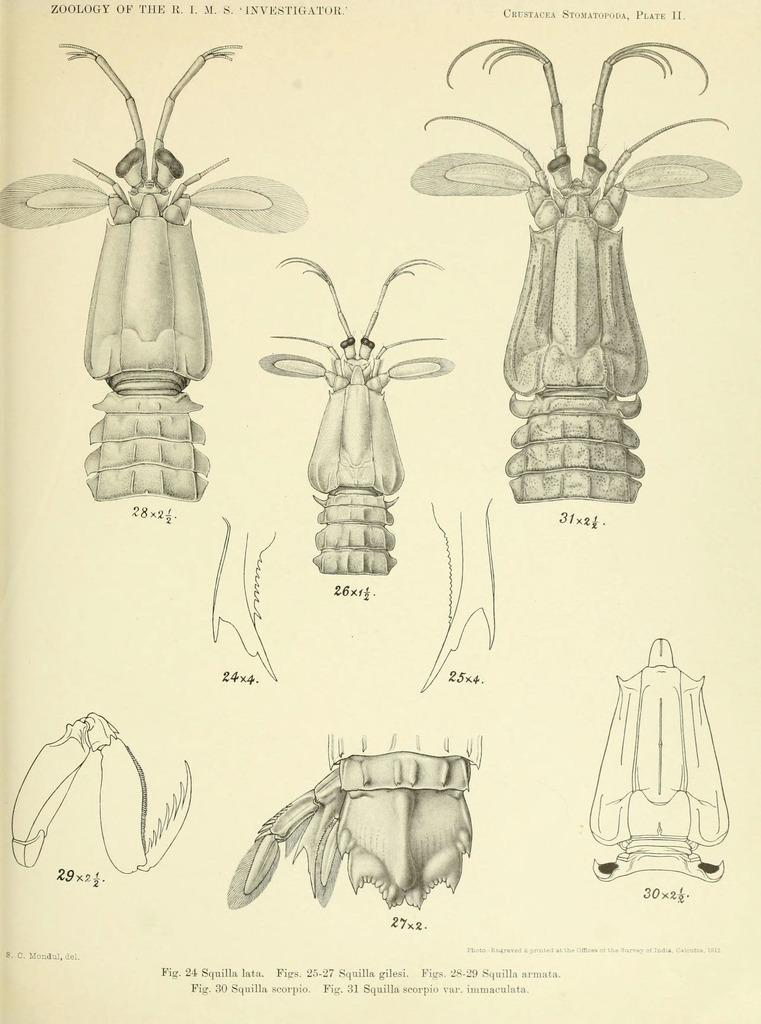What type of creatures are featured in the images in the picture? There are pictures of insects in the image. What time of day is depicted in the images of the coast with babies? There are no images of the coast or babies present in the image; it only features pictures of insects. 